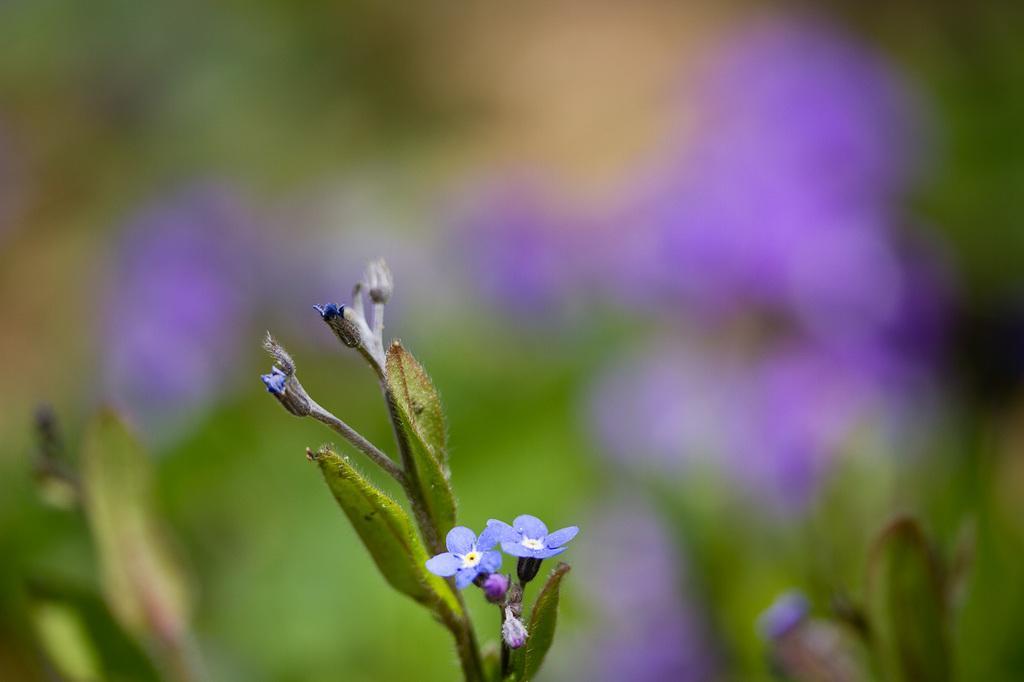Can you describe this image briefly? In this image there are leaves, there are flowers. 